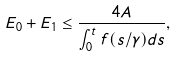Convert formula to latex. <formula><loc_0><loc_0><loc_500><loc_500>E _ { 0 } + E _ { 1 } \leq \frac { 4 A } { \int _ { 0 } ^ { t } f ( s / \gamma ) d s } ,</formula> 